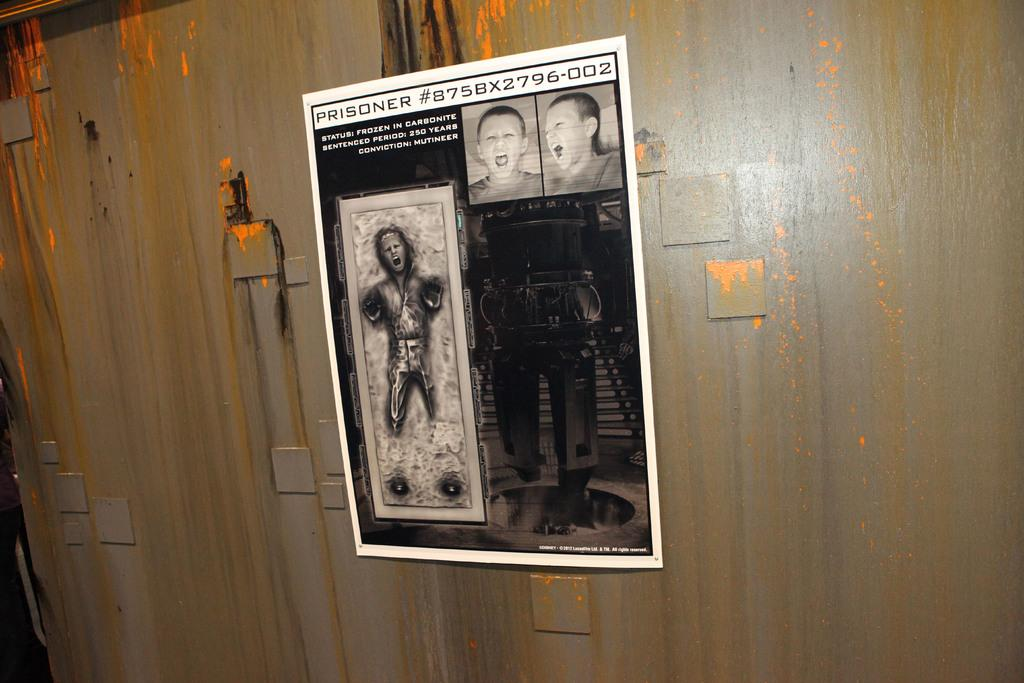<image>
Write a terse but informative summary of the picture. On a wall hangs a poster of a prisoner #875BX2796-002 who has been frozen. 